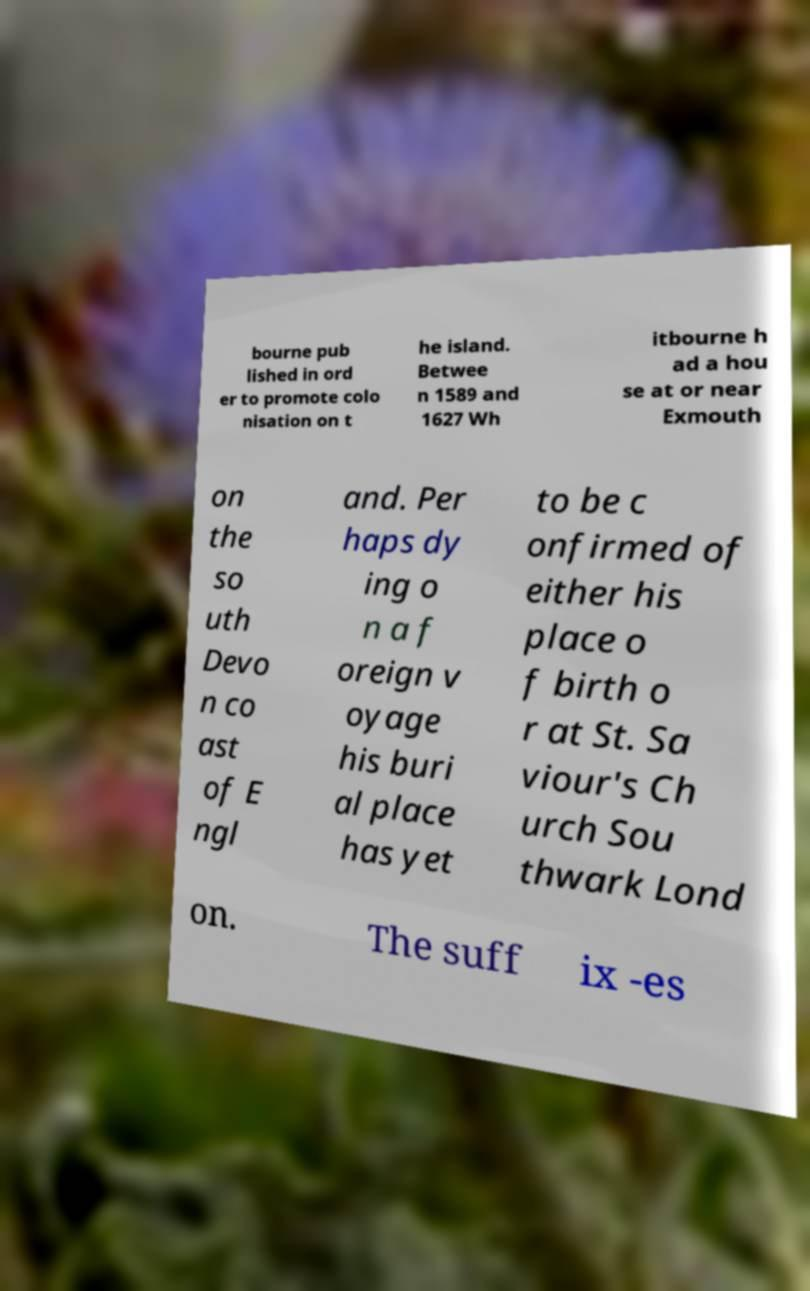What messages or text are displayed in this image? I need them in a readable, typed format. bourne pub lished in ord er to promote colo nisation on t he island. Betwee n 1589 and 1627 Wh itbourne h ad a hou se at or near Exmouth on the so uth Devo n co ast of E ngl and. Per haps dy ing o n a f oreign v oyage his buri al place has yet to be c onfirmed of either his place o f birth o r at St. Sa viour's Ch urch Sou thwark Lond on. The suff ix -es 